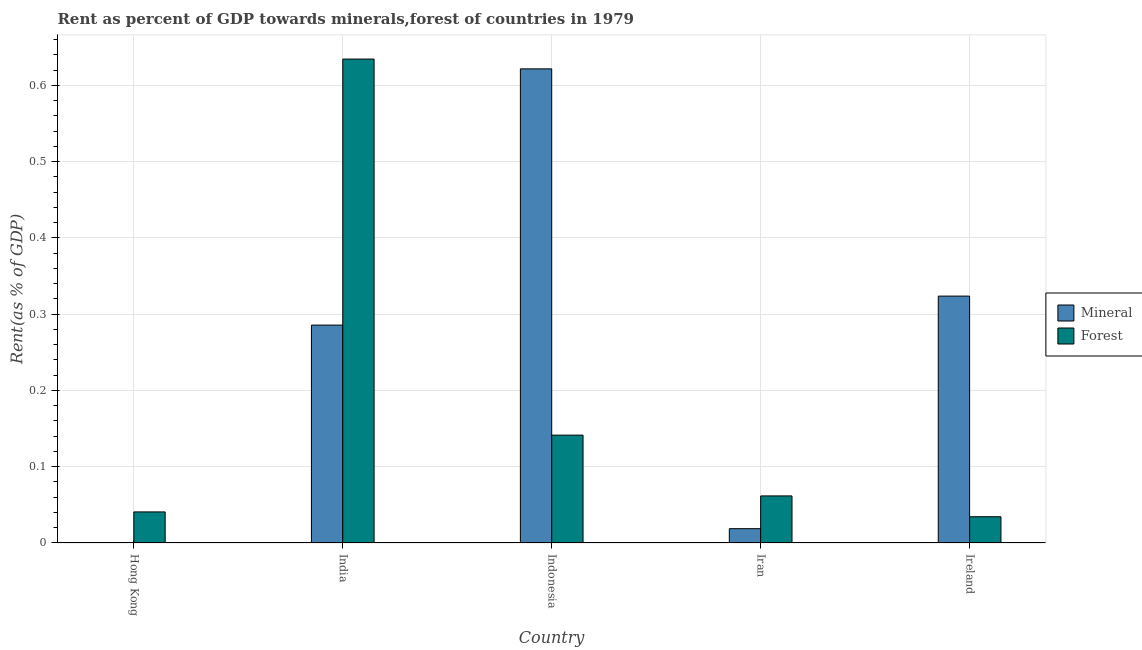How many different coloured bars are there?
Ensure brevity in your answer.  2. How many groups of bars are there?
Provide a short and direct response. 5. Are the number of bars on each tick of the X-axis equal?
Give a very brief answer. Yes. How many bars are there on the 5th tick from the left?
Your answer should be very brief. 2. How many bars are there on the 5th tick from the right?
Keep it short and to the point. 2. What is the label of the 3rd group of bars from the left?
Offer a very short reply. Indonesia. In how many cases, is the number of bars for a given country not equal to the number of legend labels?
Keep it short and to the point. 0. What is the mineral rent in India?
Offer a very short reply. 0.29. Across all countries, what is the maximum forest rent?
Give a very brief answer. 0.63. Across all countries, what is the minimum forest rent?
Your answer should be compact. 0.03. In which country was the forest rent maximum?
Make the answer very short. India. In which country was the forest rent minimum?
Offer a terse response. Ireland. What is the total mineral rent in the graph?
Offer a very short reply. 1.25. What is the difference between the forest rent in Hong Kong and that in Ireland?
Offer a very short reply. 0.01. What is the difference between the forest rent in India and the mineral rent in Ireland?
Provide a short and direct response. 0.31. What is the average mineral rent per country?
Keep it short and to the point. 0.25. What is the difference between the forest rent and mineral rent in Ireland?
Provide a succinct answer. -0.29. What is the ratio of the mineral rent in Hong Kong to that in Iran?
Your answer should be very brief. 0.01. What is the difference between the highest and the second highest mineral rent?
Your answer should be compact. 0.3. What is the difference between the highest and the lowest forest rent?
Provide a succinct answer. 0.6. Is the sum of the forest rent in Hong Kong and Iran greater than the maximum mineral rent across all countries?
Your answer should be very brief. No. What does the 2nd bar from the left in Ireland represents?
Provide a succinct answer. Forest. What does the 2nd bar from the right in Indonesia represents?
Provide a short and direct response. Mineral. How many bars are there?
Ensure brevity in your answer.  10. How many countries are there in the graph?
Provide a short and direct response. 5. Does the graph contain any zero values?
Keep it short and to the point. No. Does the graph contain grids?
Make the answer very short. Yes. How are the legend labels stacked?
Keep it short and to the point. Vertical. What is the title of the graph?
Your answer should be very brief. Rent as percent of GDP towards minerals,forest of countries in 1979. What is the label or title of the X-axis?
Offer a terse response. Country. What is the label or title of the Y-axis?
Make the answer very short. Rent(as % of GDP). What is the Rent(as % of GDP) in Mineral in Hong Kong?
Provide a short and direct response. 0. What is the Rent(as % of GDP) in Forest in Hong Kong?
Ensure brevity in your answer.  0.04. What is the Rent(as % of GDP) in Mineral in India?
Provide a succinct answer. 0.29. What is the Rent(as % of GDP) of Forest in India?
Keep it short and to the point. 0.63. What is the Rent(as % of GDP) of Mineral in Indonesia?
Ensure brevity in your answer.  0.62. What is the Rent(as % of GDP) of Forest in Indonesia?
Offer a terse response. 0.14. What is the Rent(as % of GDP) of Mineral in Iran?
Your answer should be compact. 0.02. What is the Rent(as % of GDP) in Forest in Iran?
Offer a very short reply. 0.06. What is the Rent(as % of GDP) of Mineral in Ireland?
Ensure brevity in your answer.  0.32. What is the Rent(as % of GDP) in Forest in Ireland?
Give a very brief answer. 0.03. Across all countries, what is the maximum Rent(as % of GDP) in Mineral?
Your answer should be compact. 0.62. Across all countries, what is the maximum Rent(as % of GDP) in Forest?
Provide a succinct answer. 0.63. Across all countries, what is the minimum Rent(as % of GDP) of Mineral?
Provide a succinct answer. 0. Across all countries, what is the minimum Rent(as % of GDP) in Forest?
Provide a short and direct response. 0.03. What is the total Rent(as % of GDP) of Mineral in the graph?
Offer a terse response. 1.25. What is the total Rent(as % of GDP) of Forest in the graph?
Keep it short and to the point. 0.91. What is the difference between the Rent(as % of GDP) of Mineral in Hong Kong and that in India?
Provide a short and direct response. -0.29. What is the difference between the Rent(as % of GDP) of Forest in Hong Kong and that in India?
Your response must be concise. -0.59. What is the difference between the Rent(as % of GDP) in Mineral in Hong Kong and that in Indonesia?
Give a very brief answer. -0.62. What is the difference between the Rent(as % of GDP) of Forest in Hong Kong and that in Indonesia?
Your answer should be compact. -0.1. What is the difference between the Rent(as % of GDP) in Mineral in Hong Kong and that in Iran?
Offer a terse response. -0.02. What is the difference between the Rent(as % of GDP) of Forest in Hong Kong and that in Iran?
Make the answer very short. -0.02. What is the difference between the Rent(as % of GDP) in Mineral in Hong Kong and that in Ireland?
Provide a short and direct response. -0.32. What is the difference between the Rent(as % of GDP) in Forest in Hong Kong and that in Ireland?
Offer a very short reply. 0.01. What is the difference between the Rent(as % of GDP) of Mineral in India and that in Indonesia?
Provide a short and direct response. -0.34. What is the difference between the Rent(as % of GDP) of Forest in India and that in Indonesia?
Give a very brief answer. 0.49. What is the difference between the Rent(as % of GDP) of Mineral in India and that in Iran?
Give a very brief answer. 0.27. What is the difference between the Rent(as % of GDP) in Forest in India and that in Iran?
Your answer should be compact. 0.57. What is the difference between the Rent(as % of GDP) in Mineral in India and that in Ireland?
Offer a very short reply. -0.04. What is the difference between the Rent(as % of GDP) in Forest in India and that in Ireland?
Offer a very short reply. 0.6. What is the difference between the Rent(as % of GDP) of Mineral in Indonesia and that in Iran?
Give a very brief answer. 0.6. What is the difference between the Rent(as % of GDP) of Forest in Indonesia and that in Iran?
Ensure brevity in your answer.  0.08. What is the difference between the Rent(as % of GDP) of Mineral in Indonesia and that in Ireland?
Give a very brief answer. 0.3. What is the difference between the Rent(as % of GDP) in Forest in Indonesia and that in Ireland?
Your answer should be compact. 0.11. What is the difference between the Rent(as % of GDP) in Mineral in Iran and that in Ireland?
Ensure brevity in your answer.  -0.3. What is the difference between the Rent(as % of GDP) of Forest in Iran and that in Ireland?
Provide a succinct answer. 0.03. What is the difference between the Rent(as % of GDP) in Mineral in Hong Kong and the Rent(as % of GDP) in Forest in India?
Your answer should be compact. -0.63. What is the difference between the Rent(as % of GDP) in Mineral in Hong Kong and the Rent(as % of GDP) in Forest in Indonesia?
Make the answer very short. -0.14. What is the difference between the Rent(as % of GDP) of Mineral in Hong Kong and the Rent(as % of GDP) of Forest in Iran?
Offer a very short reply. -0.06. What is the difference between the Rent(as % of GDP) of Mineral in Hong Kong and the Rent(as % of GDP) of Forest in Ireland?
Offer a terse response. -0.03. What is the difference between the Rent(as % of GDP) in Mineral in India and the Rent(as % of GDP) in Forest in Indonesia?
Ensure brevity in your answer.  0.14. What is the difference between the Rent(as % of GDP) in Mineral in India and the Rent(as % of GDP) in Forest in Iran?
Offer a terse response. 0.22. What is the difference between the Rent(as % of GDP) in Mineral in India and the Rent(as % of GDP) in Forest in Ireland?
Provide a short and direct response. 0.25. What is the difference between the Rent(as % of GDP) of Mineral in Indonesia and the Rent(as % of GDP) of Forest in Iran?
Give a very brief answer. 0.56. What is the difference between the Rent(as % of GDP) of Mineral in Indonesia and the Rent(as % of GDP) of Forest in Ireland?
Provide a short and direct response. 0.59. What is the difference between the Rent(as % of GDP) in Mineral in Iran and the Rent(as % of GDP) in Forest in Ireland?
Keep it short and to the point. -0.02. What is the average Rent(as % of GDP) in Mineral per country?
Your answer should be very brief. 0.25. What is the average Rent(as % of GDP) in Forest per country?
Your answer should be compact. 0.18. What is the difference between the Rent(as % of GDP) of Mineral and Rent(as % of GDP) of Forest in Hong Kong?
Your answer should be very brief. -0.04. What is the difference between the Rent(as % of GDP) of Mineral and Rent(as % of GDP) of Forest in India?
Give a very brief answer. -0.35. What is the difference between the Rent(as % of GDP) of Mineral and Rent(as % of GDP) of Forest in Indonesia?
Your response must be concise. 0.48. What is the difference between the Rent(as % of GDP) in Mineral and Rent(as % of GDP) in Forest in Iran?
Give a very brief answer. -0.04. What is the difference between the Rent(as % of GDP) of Mineral and Rent(as % of GDP) of Forest in Ireland?
Offer a very short reply. 0.29. What is the ratio of the Rent(as % of GDP) in Mineral in Hong Kong to that in India?
Your answer should be very brief. 0. What is the ratio of the Rent(as % of GDP) in Forest in Hong Kong to that in India?
Provide a short and direct response. 0.06. What is the ratio of the Rent(as % of GDP) in Forest in Hong Kong to that in Indonesia?
Your answer should be compact. 0.29. What is the ratio of the Rent(as % of GDP) in Mineral in Hong Kong to that in Iran?
Keep it short and to the point. 0.01. What is the ratio of the Rent(as % of GDP) of Forest in Hong Kong to that in Iran?
Ensure brevity in your answer.  0.66. What is the ratio of the Rent(as % of GDP) in Mineral in Hong Kong to that in Ireland?
Give a very brief answer. 0. What is the ratio of the Rent(as % of GDP) of Forest in Hong Kong to that in Ireland?
Keep it short and to the point. 1.18. What is the ratio of the Rent(as % of GDP) in Mineral in India to that in Indonesia?
Ensure brevity in your answer.  0.46. What is the ratio of the Rent(as % of GDP) of Forest in India to that in Indonesia?
Make the answer very short. 4.49. What is the ratio of the Rent(as % of GDP) of Mineral in India to that in Iran?
Your answer should be very brief. 15.22. What is the ratio of the Rent(as % of GDP) of Forest in India to that in Iran?
Give a very brief answer. 10.28. What is the ratio of the Rent(as % of GDP) of Mineral in India to that in Ireland?
Give a very brief answer. 0.88. What is the ratio of the Rent(as % of GDP) of Forest in India to that in Ireland?
Provide a short and direct response. 18.43. What is the ratio of the Rent(as % of GDP) of Mineral in Indonesia to that in Iran?
Your answer should be very brief. 33.12. What is the ratio of the Rent(as % of GDP) in Forest in Indonesia to that in Iran?
Offer a very short reply. 2.29. What is the ratio of the Rent(as % of GDP) of Mineral in Indonesia to that in Ireland?
Keep it short and to the point. 1.92. What is the ratio of the Rent(as % of GDP) of Forest in Indonesia to that in Ireland?
Offer a terse response. 4.11. What is the ratio of the Rent(as % of GDP) of Mineral in Iran to that in Ireland?
Keep it short and to the point. 0.06. What is the ratio of the Rent(as % of GDP) of Forest in Iran to that in Ireland?
Make the answer very short. 1.79. What is the difference between the highest and the second highest Rent(as % of GDP) in Mineral?
Ensure brevity in your answer.  0.3. What is the difference between the highest and the second highest Rent(as % of GDP) of Forest?
Your answer should be compact. 0.49. What is the difference between the highest and the lowest Rent(as % of GDP) of Mineral?
Make the answer very short. 0.62. What is the difference between the highest and the lowest Rent(as % of GDP) in Forest?
Offer a very short reply. 0.6. 